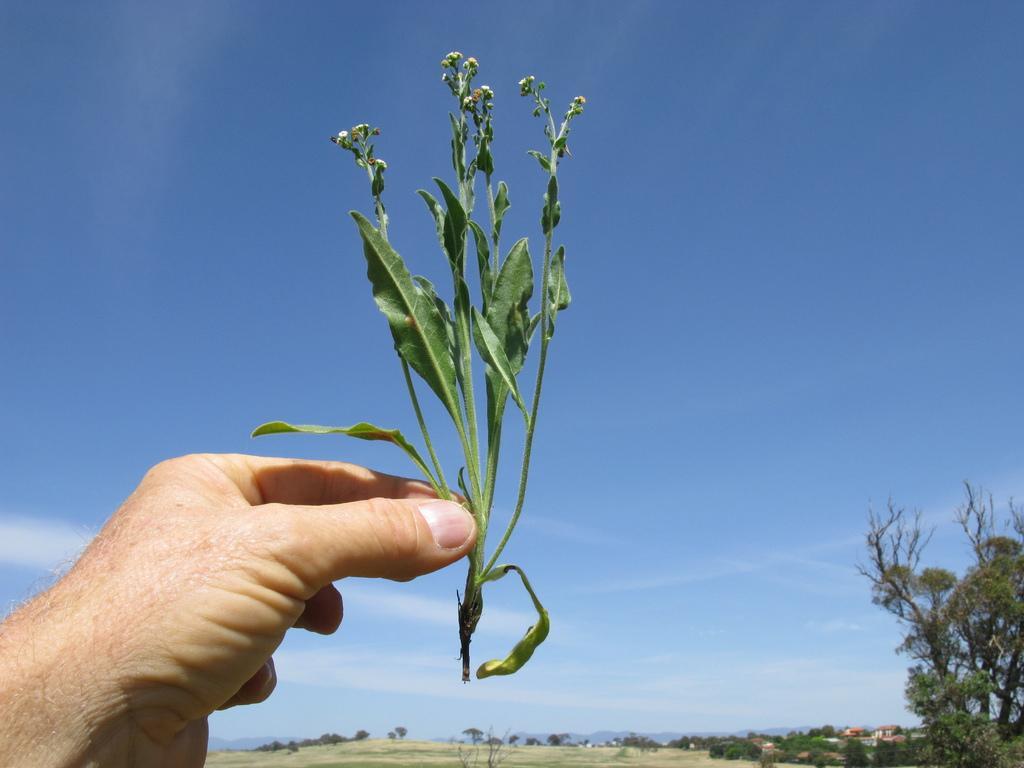Please provide a concise description of this image. In the bottom left corner of the image there is a hand of a person holding a stem with leaves. In the bottom right corner of the image there is a tree. At the bottom of the image there is ground and also there are trees. And in the background there is sky. 